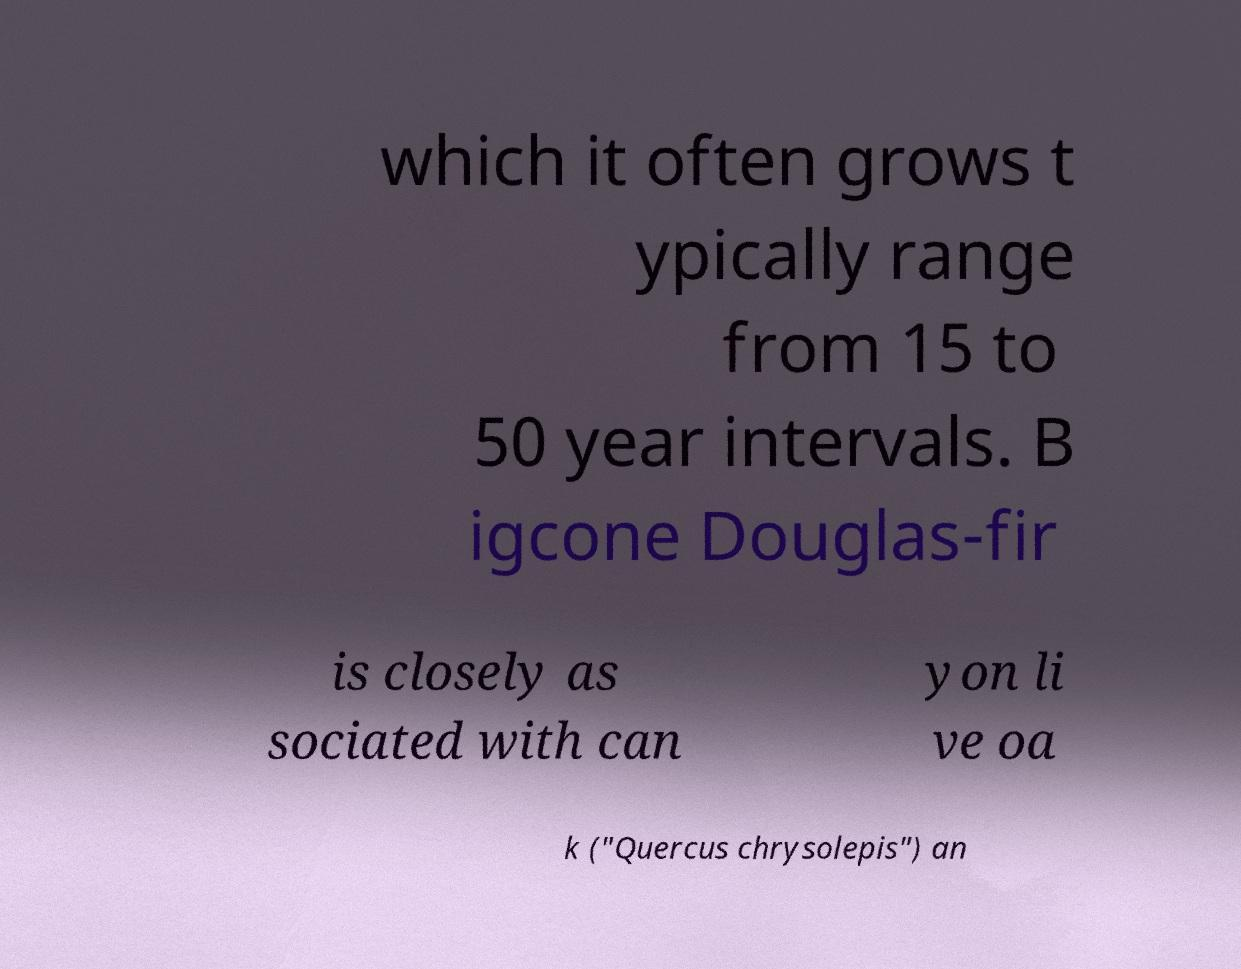Can you read and provide the text displayed in the image?This photo seems to have some interesting text. Can you extract and type it out for me? which it often grows t ypically range from 15 to 50 year intervals. B igcone Douglas-fir is closely as sociated with can yon li ve oa k ("Quercus chrysolepis") an 